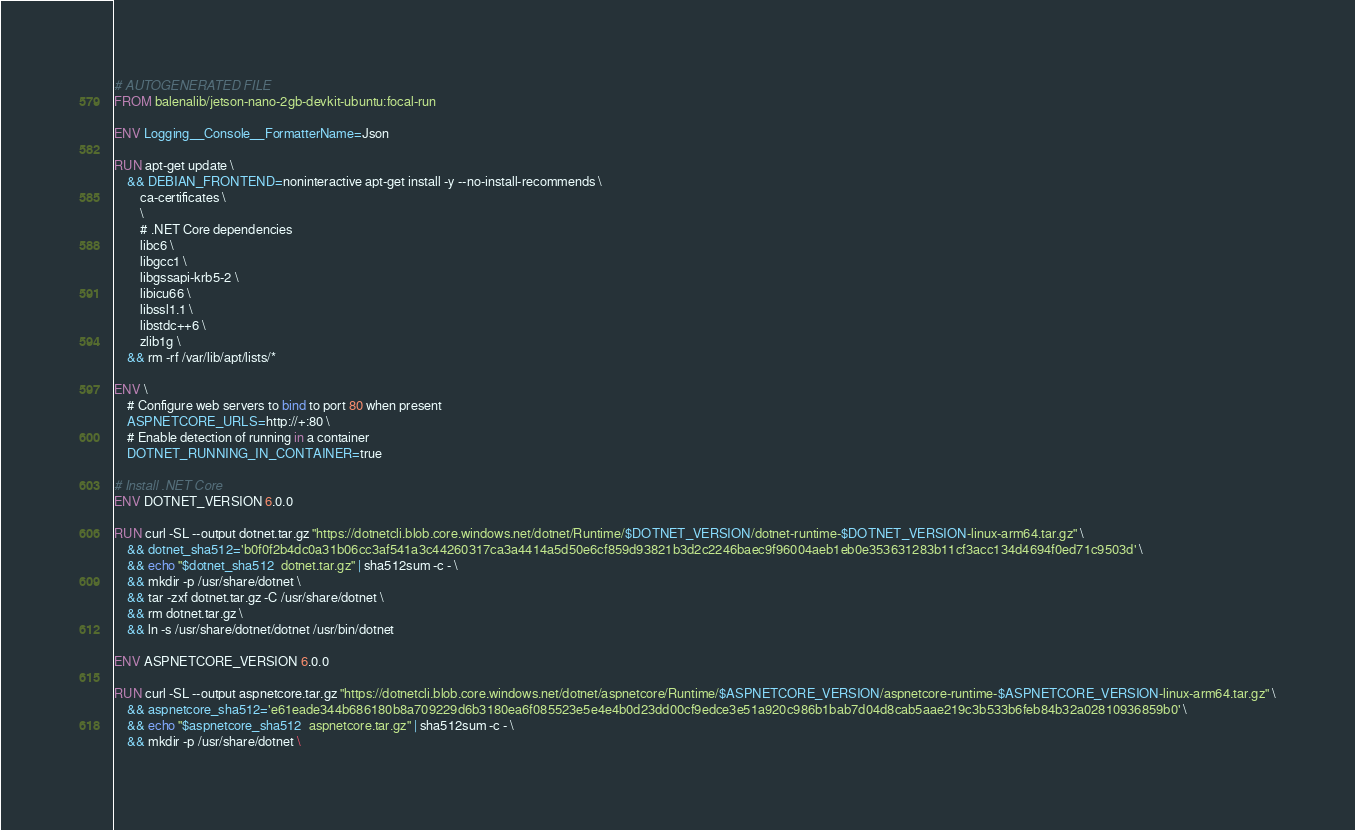<code> <loc_0><loc_0><loc_500><loc_500><_Dockerfile_># AUTOGENERATED FILE
FROM balenalib/jetson-nano-2gb-devkit-ubuntu:focal-run

ENV Logging__Console__FormatterName=Json

RUN apt-get update \
    && DEBIAN_FRONTEND=noninteractive apt-get install -y --no-install-recommends \
        ca-certificates \
        \
        # .NET Core dependencies
        libc6 \
        libgcc1 \
        libgssapi-krb5-2 \
        libicu66 \
        libssl1.1 \
        libstdc++6 \
        zlib1g \
    && rm -rf /var/lib/apt/lists/*

ENV \
    # Configure web servers to bind to port 80 when present
    ASPNETCORE_URLS=http://+:80 \
    # Enable detection of running in a container
    DOTNET_RUNNING_IN_CONTAINER=true

# Install .NET Core
ENV DOTNET_VERSION 6.0.0

RUN curl -SL --output dotnet.tar.gz "https://dotnetcli.blob.core.windows.net/dotnet/Runtime/$DOTNET_VERSION/dotnet-runtime-$DOTNET_VERSION-linux-arm64.tar.gz" \
    && dotnet_sha512='b0f0f2b4dc0a31b06cc3af541a3c44260317ca3a4414a5d50e6cf859d93821b3d2c2246baec9f96004aeb1eb0e353631283b11cf3acc134d4694f0ed71c9503d' \
    && echo "$dotnet_sha512  dotnet.tar.gz" | sha512sum -c - \
    && mkdir -p /usr/share/dotnet \
    && tar -zxf dotnet.tar.gz -C /usr/share/dotnet \
    && rm dotnet.tar.gz \
    && ln -s /usr/share/dotnet/dotnet /usr/bin/dotnet

ENV ASPNETCORE_VERSION 6.0.0

RUN curl -SL --output aspnetcore.tar.gz "https://dotnetcli.blob.core.windows.net/dotnet/aspnetcore/Runtime/$ASPNETCORE_VERSION/aspnetcore-runtime-$ASPNETCORE_VERSION-linux-arm64.tar.gz" \
    && aspnetcore_sha512='e61eade344b686180b8a709229d6b3180ea6f085523e5e4e4b0d23dd00cf9edce3e51a920c986b1bab7d04d8cab5aae219c3b533b6feb84b32a02810936859b0' \
    && echo "$aspnetcore_sha512  aspnetcore.tar.gz" | sha512sum -c - \
    && mkdir -p /usr/share/dotnet \</code> 